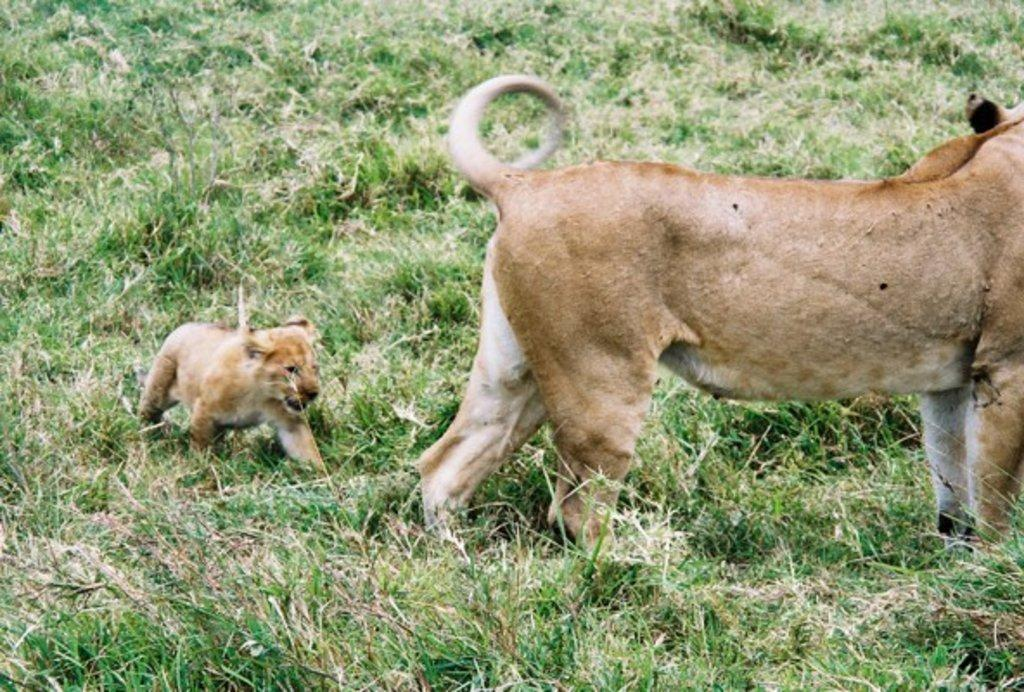What animal is the main subject of the image? There is a lion in the image. What type of terrain is the lion standing on? The lion is standing on the grassland. Is there another lion in the image? Yes, there is a cub in the image. What is the cub doing in relation to the lion? The cub is following the lion. What type of glass is the lion drinking from in the image? There is no glass present in the image, and the lion is not drinking from anything. 